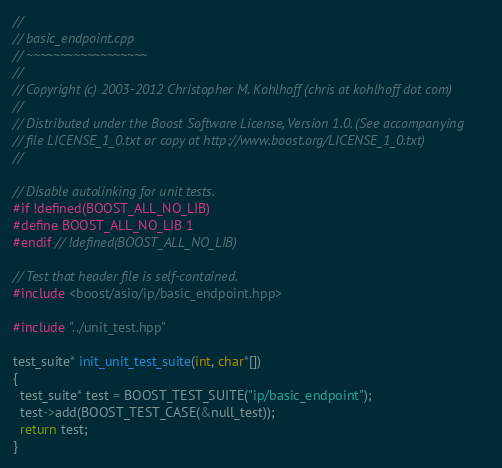<code> <loc_0><loc_0><loc_500><loc_500><_C++_>//
// basic_endpoint.cpp
// ~~~~~~~~~~~~~~~~~~
//
// Copyright (c) 2003-2012 Christopher M. Kohlhoff (chris at kohlhoff dot com)
//
// Distributed under the Boost Software License, Version 1.0. (See accompanying
// file LICENSE_1_0.txt or copy at http://www.boost.org/LICENSE_1_0.txt)
//

// Disable autolinking for unit tests.
#if !defined(BOOST_ALL_NO_LIB)
#define BOOST_ALL_NO_LIB 1
#endif // !defined(BOOST_ALL_NO_LIB)

// Test that header file is self-contained.
#include <boost/asio/ip/basic_endpoint.hpp>

#include "../unit_test.hpp"

test_suite* init_unit_test_suite(int, char*[])
{
  test_suite* test = BOOST_TEST_SUITE("ip/basic_endpoint");
  test->add(BOOST_TEST_CASE(&null_test));
  return test;
}
</code> 